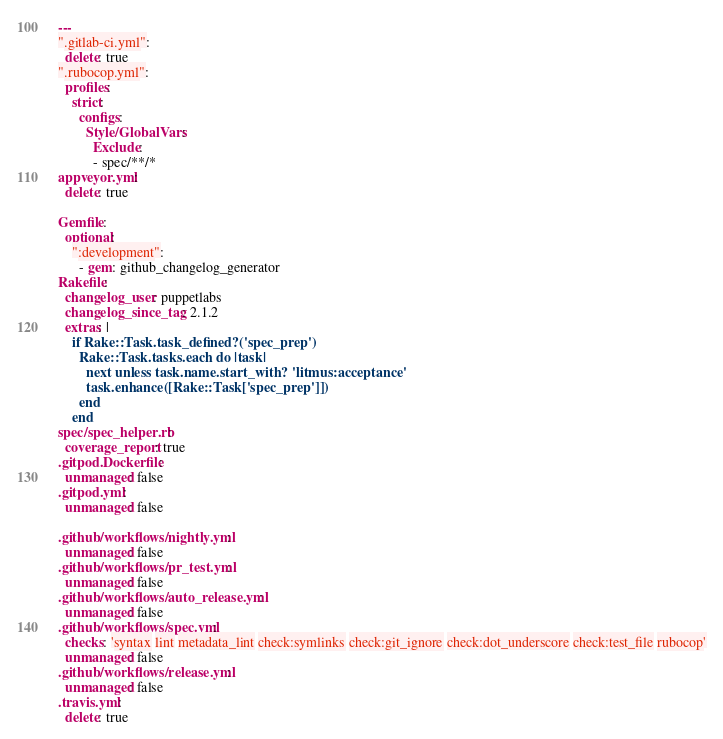Convert code to text. <code><loc_0><loc_0><loc_500><loc_500><_YAML_>---
".gitlab-ci.yml":
  delete: true
".rubocop.yml":
  profiles:
    strict:
      configs:
        Style/GlobalVars:
          Exclude:
          - spec/**/*
appveyor.yml:
  delete: true

Gemfile:
  optional:
    ":development":
      - gem: github_changelog_generator
Rakefile:
  changelog_user: puppetlabs
  changelog_since_tag: 2.1.2
  extras: |
    if Rake::Task.task_defined?('spec_prep')
      Rake::Task.tasks.each do |task|
        next unless task.name.start_with? 'litmus:acceptance'
        task.enhance([Rake::Task['spec_prep']])
      end
    end
spec/spec_helper.rb:
  coverage_report: true
.gitpod.Dockerfile:
  unmanaged: false
.gitpod.yml:
  unmanaged: false

.github/workflows/nightly.yml:
  unmanaged: false
.github/workflows/pr_test.yml:
  unmanaged: false
.github/workflows/auto_release.yml:
  unmanaged: false
.github/workflows/spec.yml:
  checks: 'syntax lint metadata_lint check:symlinks check:git_ignore check:dot_underscore check:test_file rubocop'
  unmanaged: false
.github/workflows/release.yml:
  unmanaged: false
.travis.yml:
  delete: true
</code> 